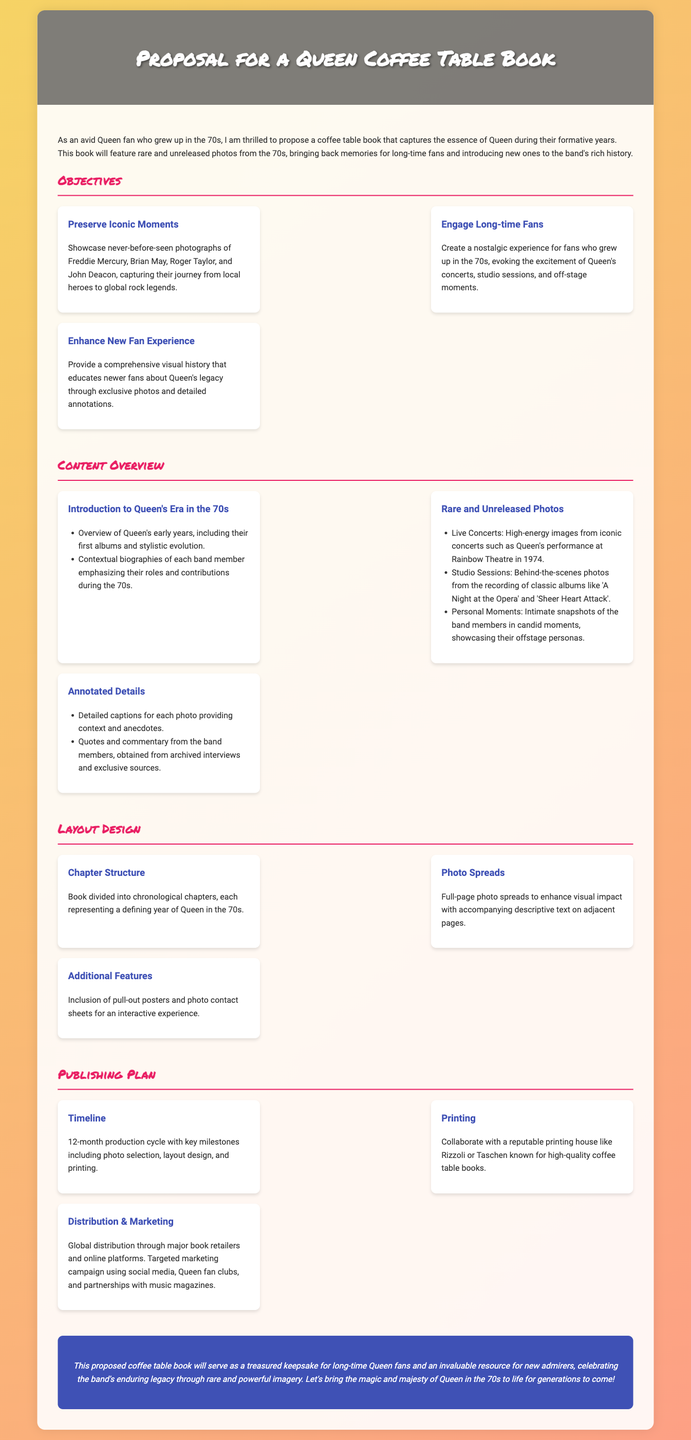What is the main subject of the proposal? The proposal focuses on creating a coffee table book featuring rare and unreleased photos of Queen from the 70s.
Answer: coffee table book How many objectives are outlined in the proposal? The proposal lists three objectives related to preserving moments, engaging fans, and enhancing experiences.
Answer: three Which notable concert is mentioned for live photos in the content overview? The proposal specifically highlights Queen's performance at the Rainbow Theatre in 1974.
Answer: Rainbow Theatre What is the duration of the proposed production cycle? The proposal states a production cycle of 12 months from start to finish.
Answer: 12 months Which companies are suggested for collaboration in printing? Rizzoli and Taschen are mentioned as reputable printing houses for the coffee table book.
Answer: Rizzoli or Taschen What feature is included for interaction in the layout design? The proposal includes pull-out posters and photo contact sheets for an interactive experience.
Answer: pull-out posters What is highlighted under the publishing plan related to distribution? The proposal mentions global distribution through major book retailers and online platforms.
Answer: global distribution What aspect of Queen's history does the proposal aim to educate new fans about? The proposal aims to provide a comprehensive visual history of Queen’s legacy through exclusive photos.
Answer: Queen's legacy 